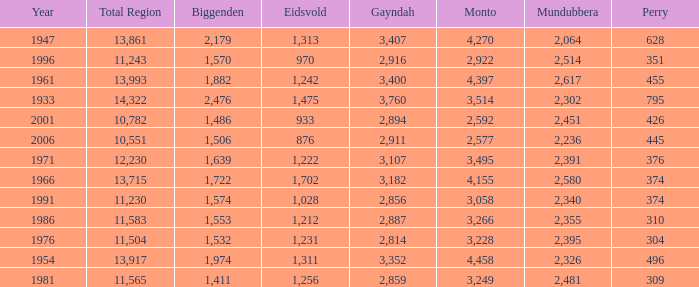What is the Total Region number of hte one that has Eidsvold at 970 and Biggenden larger than 1,570? 0.0. 